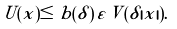Convert formula to latex. <formula><loc_0><loc_0><loc_500><loc_500>U ( x ) \leq b ( \delta ) \, \varepsilon \, V ( \delta | x | ) .</formula> 